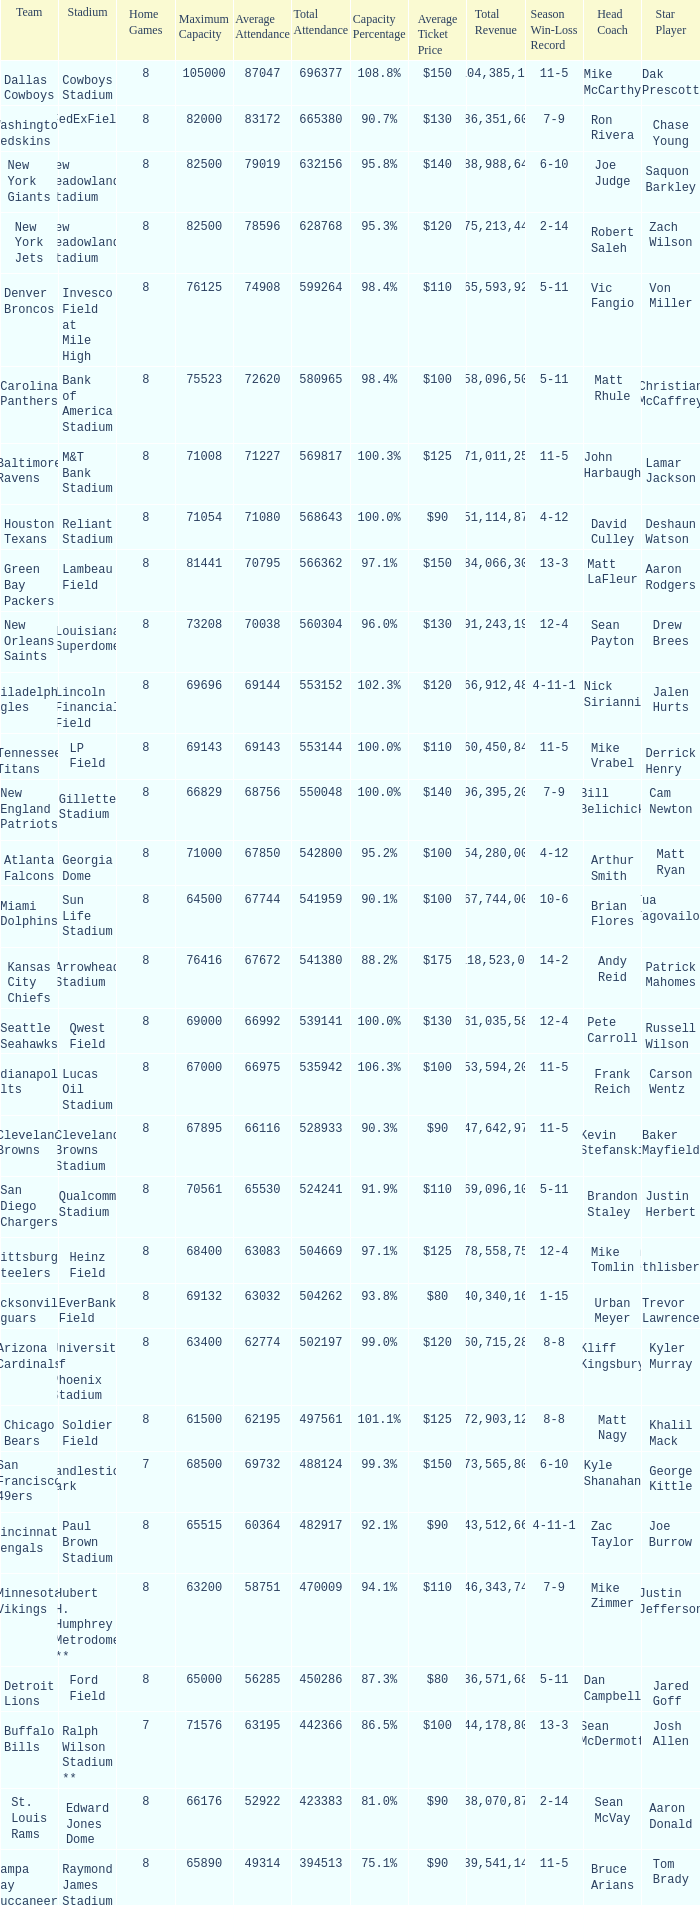What was the capacity percentage when attendance was 71080? 100.0%. 